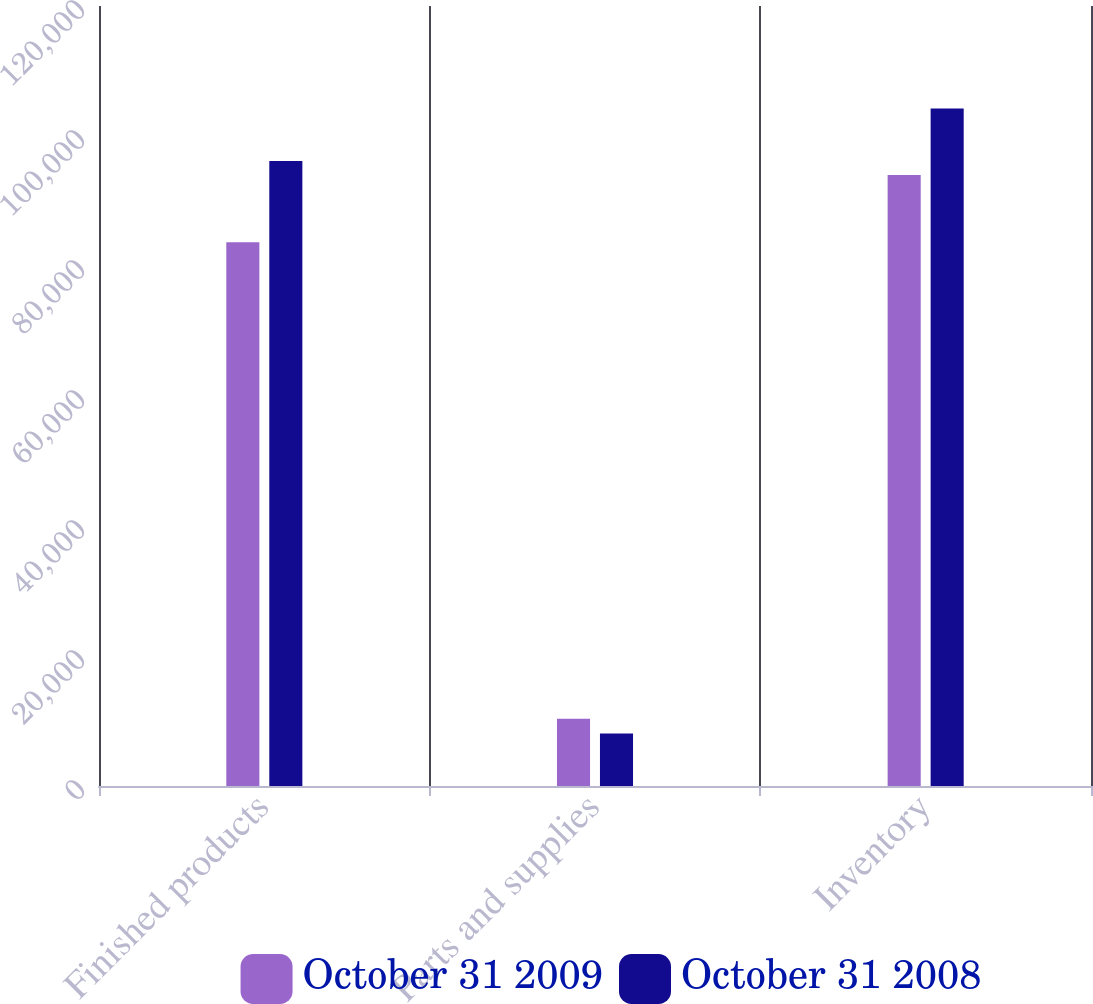<chart> <loc_0><loc_0><loc_500><loc_500><stacked_bar_chart><ecel><fcel>Finished products<fcel>Parts and supplies<fcel>Inventory<nl><fcel>October 31 2009<fcel>83637<fcel>10359<fcel>93996<nl><fcel>October 31 2008<fcel>96139<fcel>8096<fcel>104235<nl></chart> 